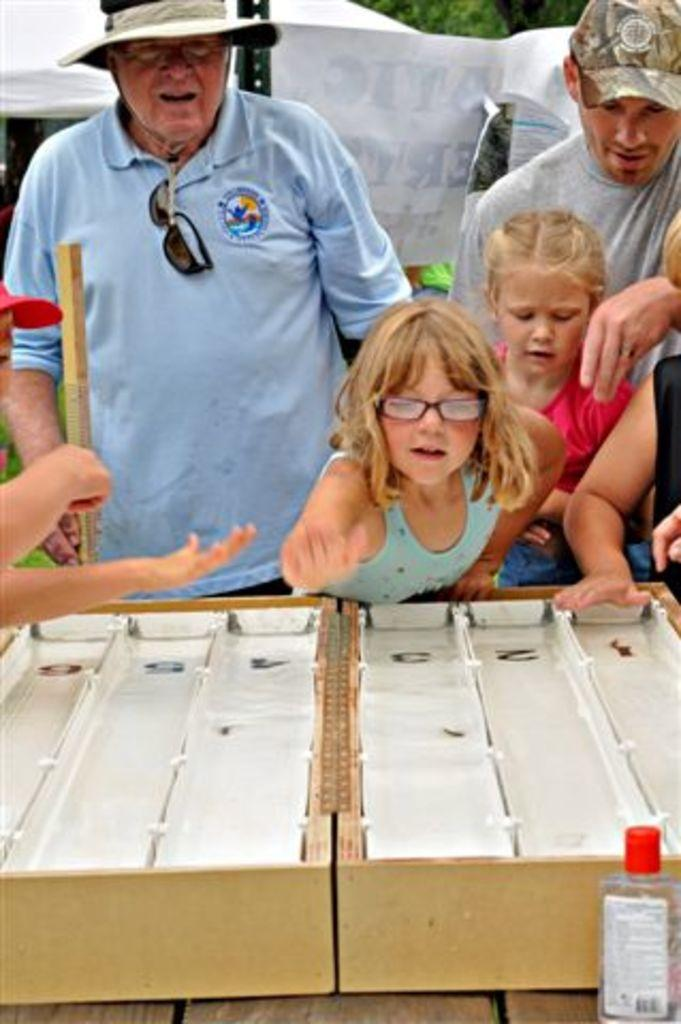How many people are in the image? There is a group of people in the image, but the exact number is not specified. What are the people in the image doing? The provided facts do not specify what the people are doing, only that they are standing in front of a table. What is on the table in the image? There is a wooden box on the table in the image. What type of kettle is on the table in the image? There is no kettle present in the image; only a wooden box is mentioned. How does the crook fit into the image? There is no crook mentioned or depicted in the image. 